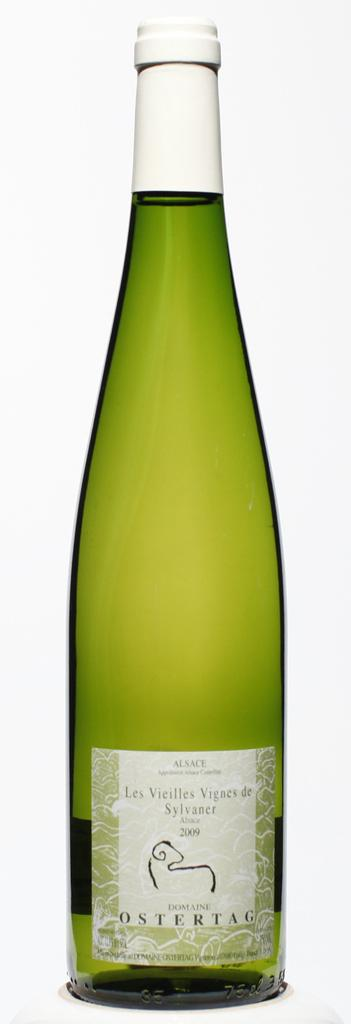What color is the bottle in the image? The bottle in the image is green. What color is the cap of the bottle? The cap of the bottle is white in color. What can be found on the bottle besides its color and cap? There is text on the bottle, which includes "ostertag." What type of ship is docked near the bottle in the image? There is no ship present in the image; it only features a green bottle with a white cap and text that includes "ostertag." 